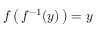Convert formula to latex. <formula><loc_0><loc_0><loc_500><loc_500>f \left ( \, f ^ { - 1 } ( y ) \, \right ) = y</formula> 